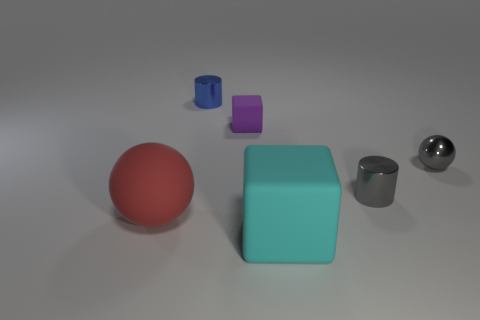There is a gray object that is the same material as the gray ball; what size is it?
Keep it short and to the point. Small. What number of metallic cylinders are the same color as the small ball?
Give a very brief answer. 1. There is a cylinder that is the same color as the tiny metallic ball; what is its size?
Your answer should be very brief. Small. There is a small metal ball; is it the same color as the metallic cylinder that is in front of the tiny blue cylinder?
Provide a short and direct response. Yes. Are there any other things that are the same color as the tiny sphere?
Your answer should be very brief. Yes. There is a sphere to the right of the large rubber thing that is to the left of the tiny blue thing; what is its material?
Offer a terse response. Metal. Are the large cyan cube and the cylinder on the right side of the tiny blue object made of the same material?
Give a very brief answer. No. How many things are metal cylinders left of the big matte block or large blocks?
Provide a short and direct response. 2. Are there any things that have the same color as the tiny ball?
Keep it short and to the point. Yes. There is a cyan thing; does it have the same shape as the small metal thing that is behind the metallic ball?
Offer a very short reply. No. 